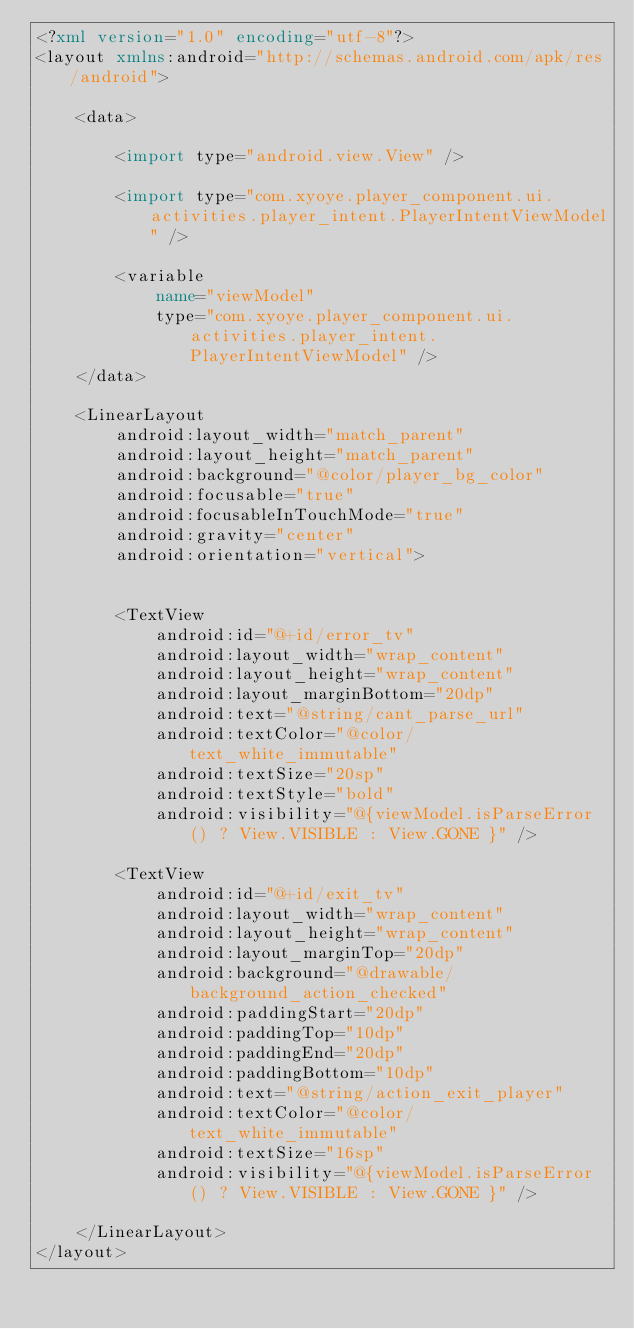Convert code to text. <code><loc_0><loc_0><loc_500><loc_500><_XML_><?xml version="1.0" encoding="utf-8"?>
<layout xmlns:android="http://schemas.android.com/apk/res/android">

    <data>

        <import type="android.view.View" />

        <import type="com.xyoye.player_component.ui.activities.player_intent.PlayerIntentViewModel" />

        <variable
            name="viewModel"
            type="com.xyoye.player_component.ui.activities.player_intent.PlayerIntentViewModel" />
    </data>

    <LinearLayout
        android:layout_width="match_parent"
        android:layout_height="match_parent"
        android:background="@color/player_bg_color"
        android:focusable="true"
        android:focusableInTouchMode="true"
        android:gravity="center"
        android:orientation="vertical">


        <TextView
            android:id="@+id/error_tv"
            android:layout_width="wrap_content"
            android:layout_height="wrap_content"
            android:layout_marginBottom="20dp"
            android:text="@string/cant_parse_url"
            android:textColor="@color/text_white_immutable"
            android:textSize="20sp"
            android:textStyle="bold"
            android:visibility="@{viewModel.isParseError() ? View.VISIBLE : View.GONE }" />

        <TextView
            android:id="@+id/exit_tv"
            android:layout_width="wrap_content"
            android:layout_height="wrap_content"
            android:layout_marginTop="20dp"
            android:background="@drawable/background_action_checked"
            android:paddingStart="20dp"
            android:paddingTop="10dp"
            android:paddingEnd="20dp"
            android:paddingBottom="10dp"
            android:text="@string/action_exit_player"
            android:textColor="@color/text_white_immutable"
            android:textSize="16sp"
            android:visibility="@{viewModel.isParseError() ? View.VISIBLE : View.GONE }" />

    </LinearLayout>
</layout></code> 